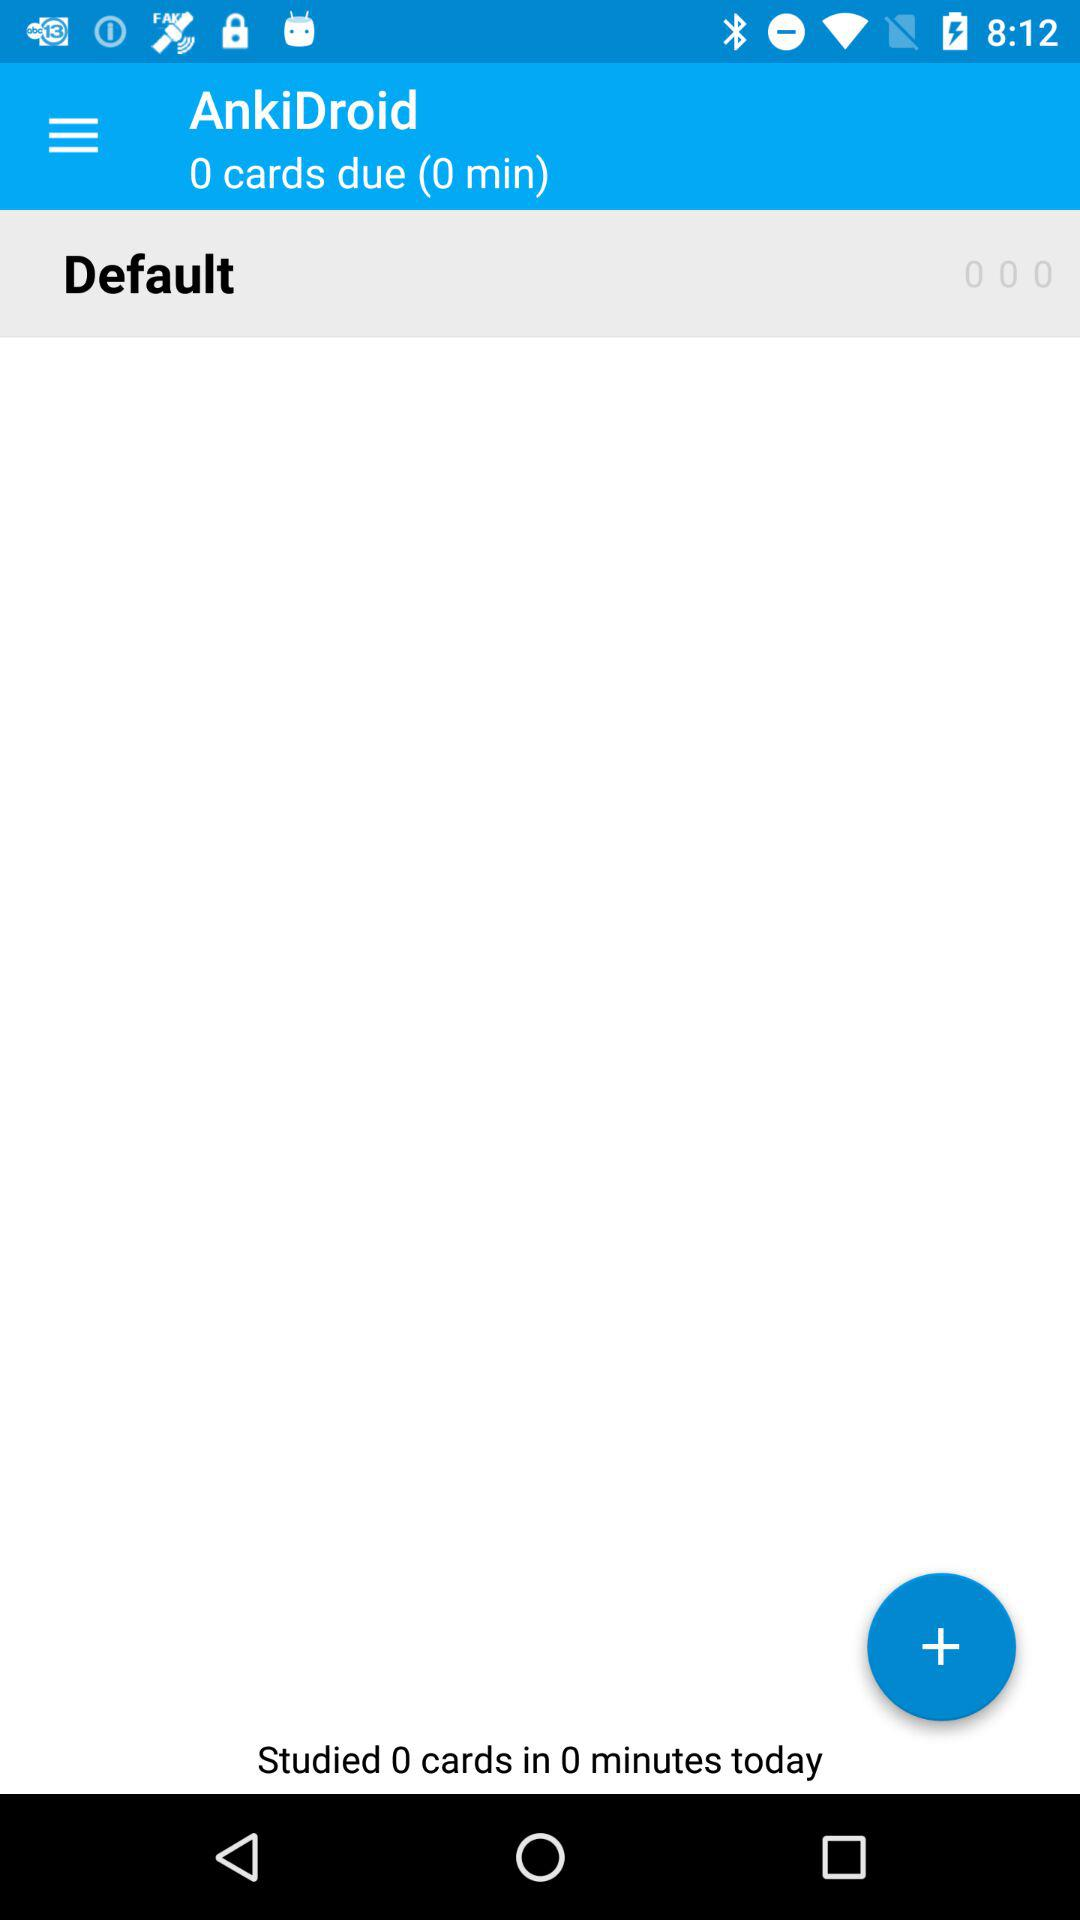How many minutes have I studied today?
Answer the question using a single word or phrase. 0 